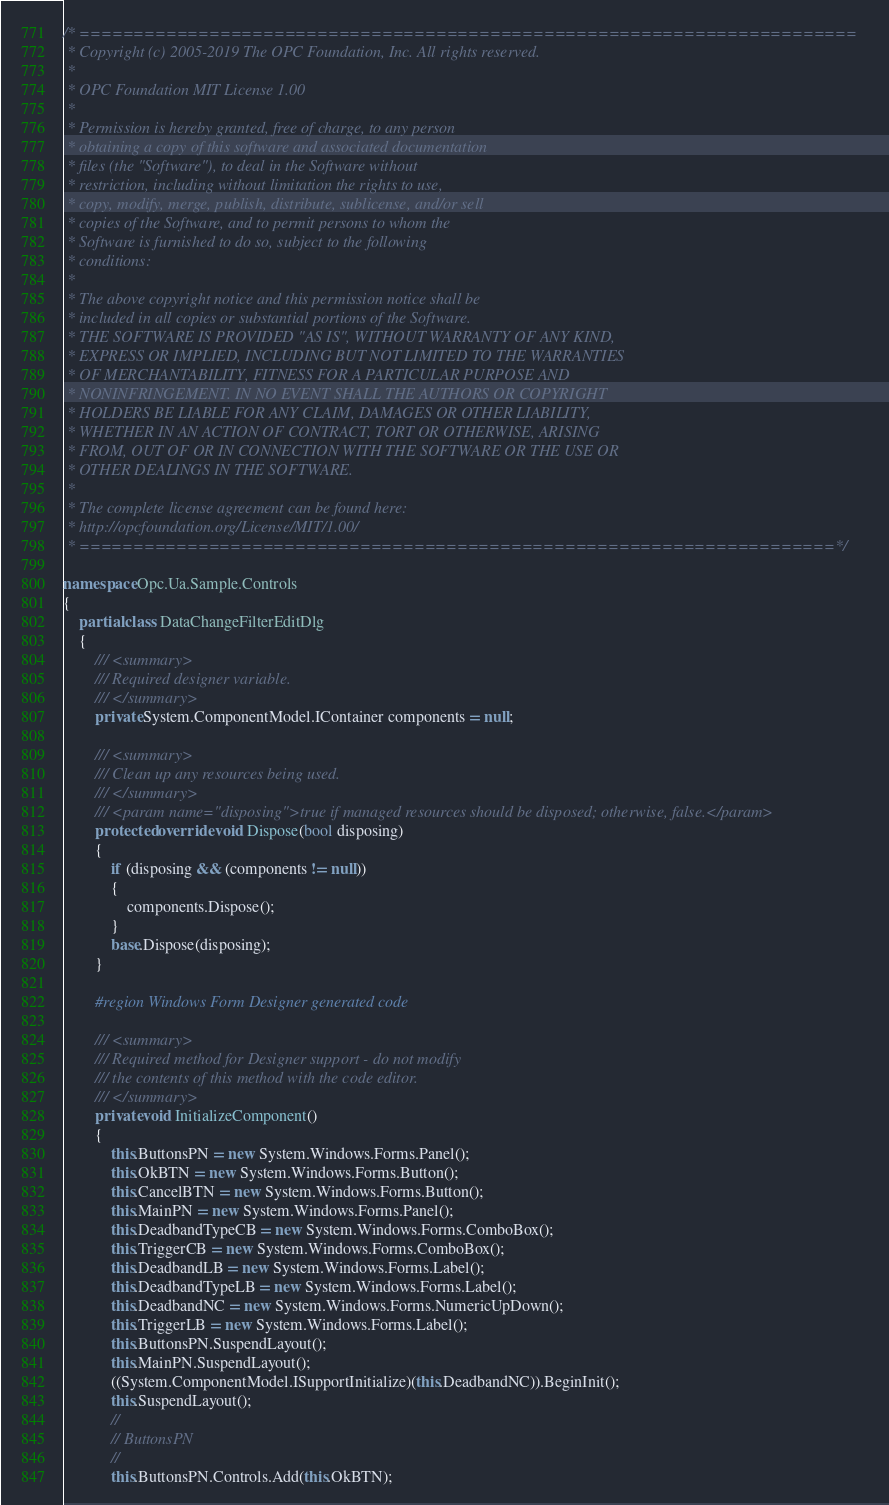Convert code to text. <code><loc_0><loc_0><loc_500><loc_500><_C#_>/* ========================================================================
 * Copyright (c) 2005-2019 The OPC Foundation, Inc. All rights reserved.
 *
 * OPC Foundation MIT License 1.00
 * 
 * Permission is hereby granted, free of charge, to any person
 * obtaining a copy of this software and associated documentation
 * files (the "Software"), to deal in the Software without
 * restriction, including without limitation the rights to use,
 * copy, modify, merge, publish, distribute, sublicense, and/or sell
 * copies of the Software, and to permit persons to whom the
 * Software is furnished to do so, subject to the following
 * conditions:
 * 
 * The above copyright notice and this permission notice shall be
 * included in all copies or substantial portions of the Software.
 * THE SOFTWARE IS PROVIDED "AS IS", WITHOUT WARRANTY OF ANY KIND,
 * EXPRESS OR IMPLIED, INCLUDING BUT NOT LIMITED TO THE WARRANTIES
 * OF MERCHANTABILITY, FITNESS FOR A PARTICULAR PURPOSE AND
 * NONINFRINGEMENT. IN NO EVENT SHALL THE AUTHORS OR COPYRIGHT
 * HOLDERS BE LIABLE FOR ANY CLAIM, DAMAGES OR OTHER LIABILITY,
 * WHETHER IN AN ACTION OF CONTRACT, TORT OR OTHERWISE, ARISING
 * FROM, OUT OF OR IN CONNECTION WITH THE SOFTWARE OR THE USE OR
 * OTHER DEALINGS IN THE SOFTWARE.
 *
 * The complete license agreement can be found here:
 * http://opcfoundation.org/License/MIT/1.00/
 * ======================================================================*/

namespace Opc.Ua.Sample.Controls
{
    partial class DataChangeFilterEditDlg
    {
        /// <summary>
        /// Required designer variable.
        /// </summary>
        private System.ComponentModel.IContainer components = null;

        /// <summary>
        /// Clean up any resources being used.
        /// </summary>
        /// <param name="disposing">true if managed resources should be disposed; otherwise, false.</param>
        protected override void Dispose(bool disposing)
        {
            if (disposing && (components != null))
            {
                components.Dispose();
            }
            base.Dispose(disposing);
        }

        #region Windows Form Designer generated code

        /// <summary>
        /// Required method for Designer support - do not modify
        /// the contents of this method with the code editor.
        /// </summary>
        private void InitializeComponent()
        {
            this.ButtonsPN = new System.Windows.Forms.Panel();
            this.OkBTN = new System.Windows.Forms.Button();
            this.CancelBTN = new System.Windows.Forms.Button();
            this.MainPN = new System.Windows.Forms.Panel();
            this.DeadbandTypeCB = new System.Windows.Forms.ComboBox();
            this.TriggerCB = new System.Windows.Forms.ComboBox();
            this.DeadbandLB = new System.Windows.Forms.Label();
            this.DeadbandTypeLB = new System.Windows.Forms.Label();
            this.DeadbandNC = new System.Windows.Forms.NumericUpDown();
            this.TriggerLB = new System.Windows.Forms.Label();
            this.ButtonsPN.SuspendLayout();
            this.MainPN.SuspendLayout();
            ((System.ComponentModel.ISupportInitialize)(this.DeadbandNC)).BeginInit();
            this.SuspendLayout();
            // 
            // ButtonsPN
            // 
            this.ButtonsPN.Controls.Add(this.OkBTN);</code> 